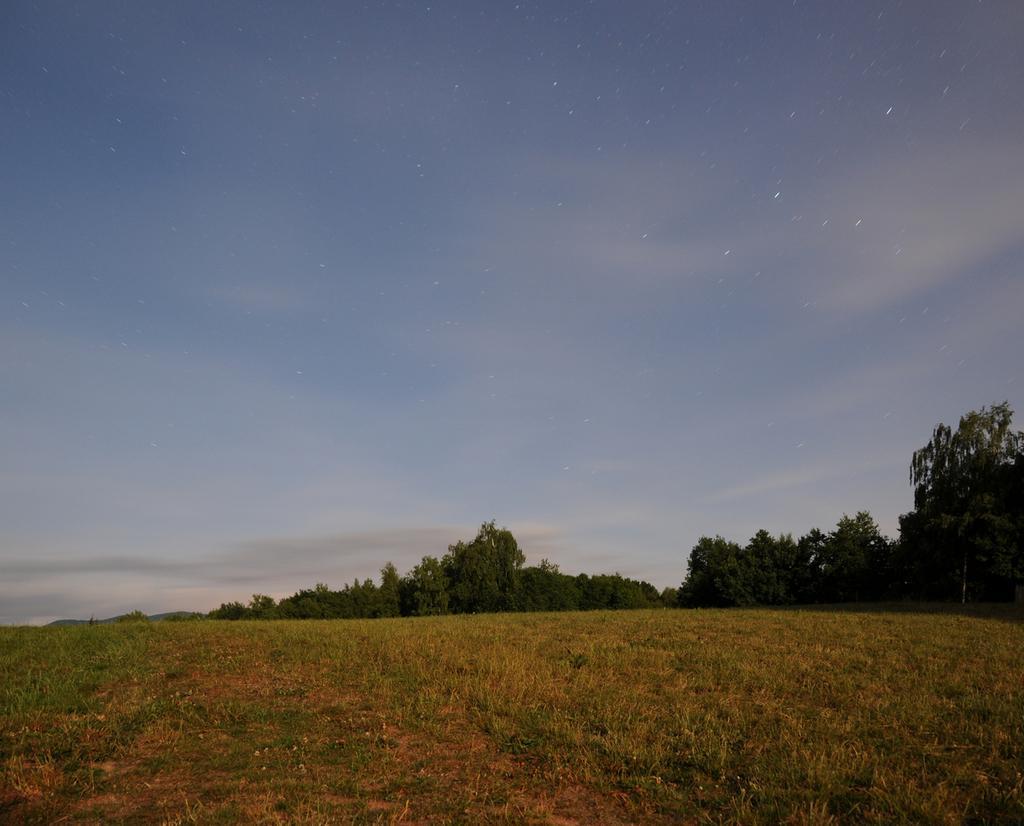Could you give a brief overview of what you see in this image? In this image I can see grass and trees in green color. Background the sky is in blue and white color. 